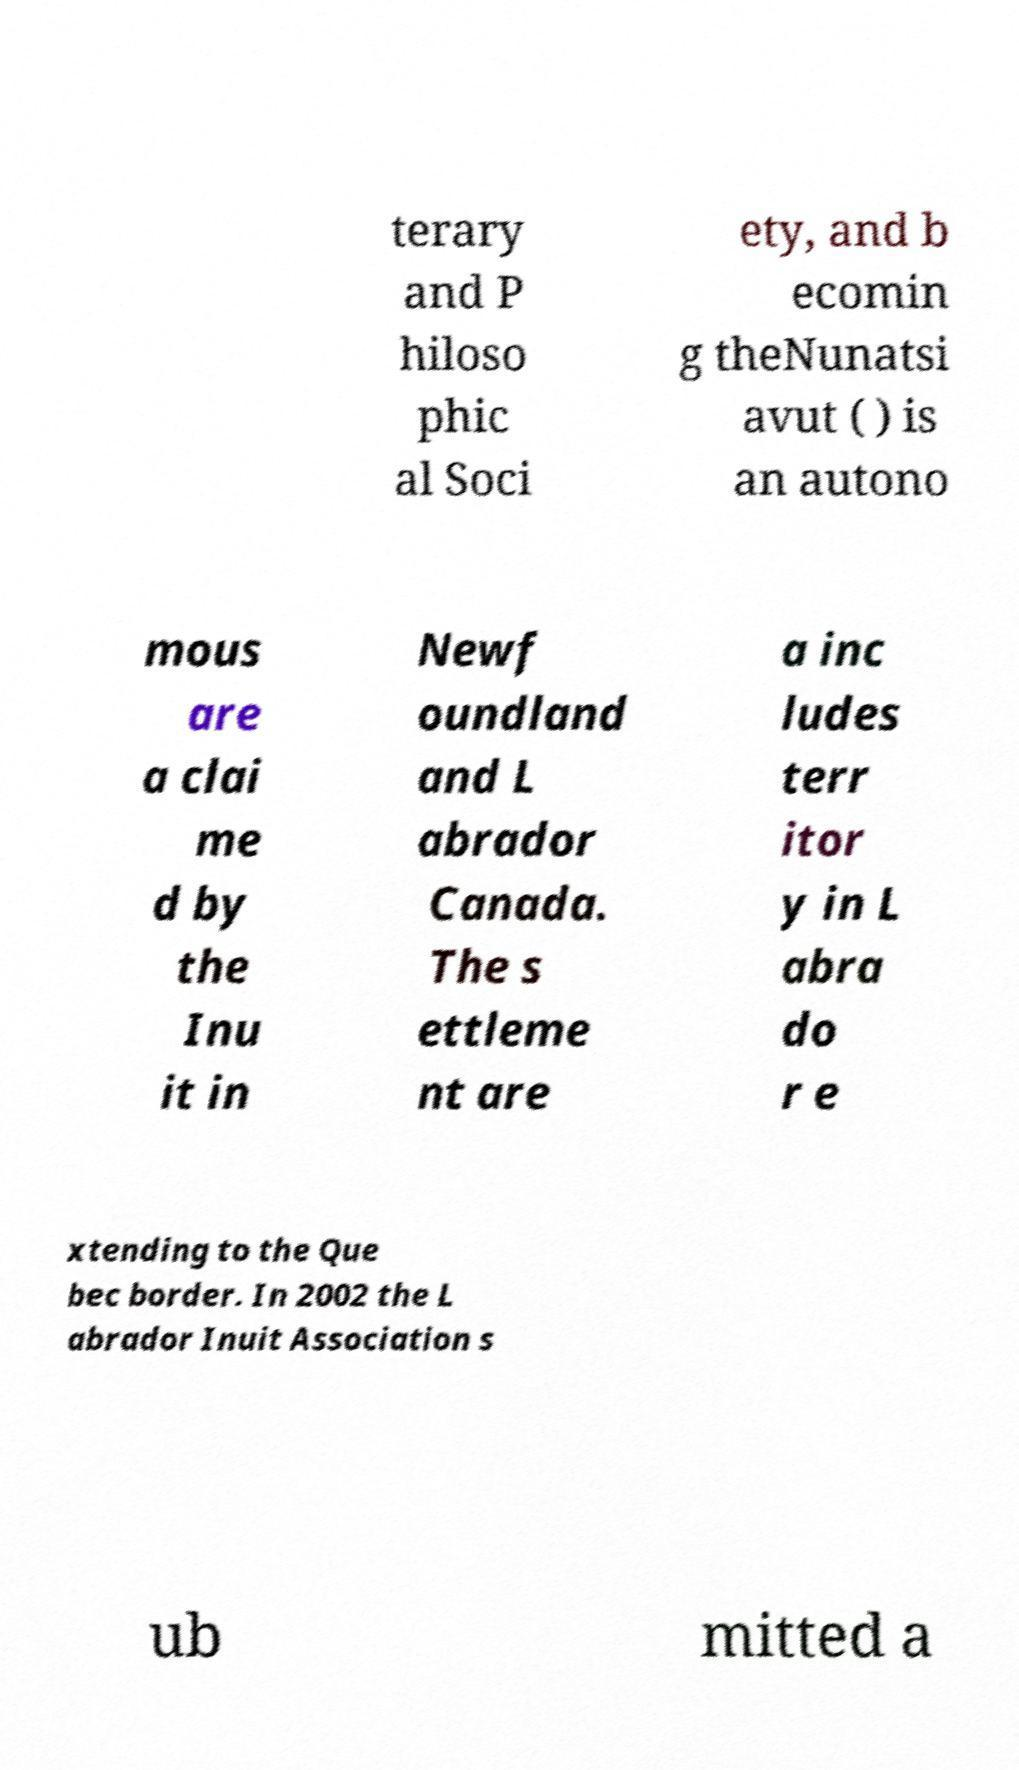Can you read and provide the text displayed in the image?This photo seems to have some interesting text. Can you extract and type it out for me? terary and P hiloso phic al Soci ety, and b ecomin g theNunatsi avut ( ) is an autono mous are a clai me d by the Inu it in Newf oundland and L abrador Canada. The s ettleme nt are a inc ludes terr itor y in L abra do r e xtending to the Que bec border. In 2002 the L abrador Inuit Association s ub mitted a 